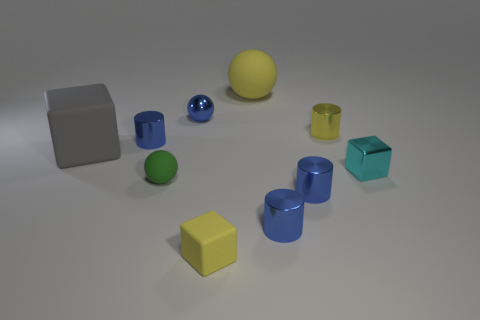Subtract all cyan spheres. How many blue cylinders are left? 3 Subtract all rubber cubes. How many cubes are left? 1 Subtract all yellow cylinders. How many cylinders are left? 3 Subtract all green cylinders. Subtract all gray balls. How many cylinders are left? 4 Subtract all cubes. How many objects are left? 7 Add 7 metallic spheres. How many metallic spheres exist? 8 Subtract 0 cyan balls. How many objects are left? 10 Subtract all tiny metallic spheres. Subtract all gray matte cubes. How many objects are left? 8 Add 2 blue metallic things. How many blue metallic things are left? 6 